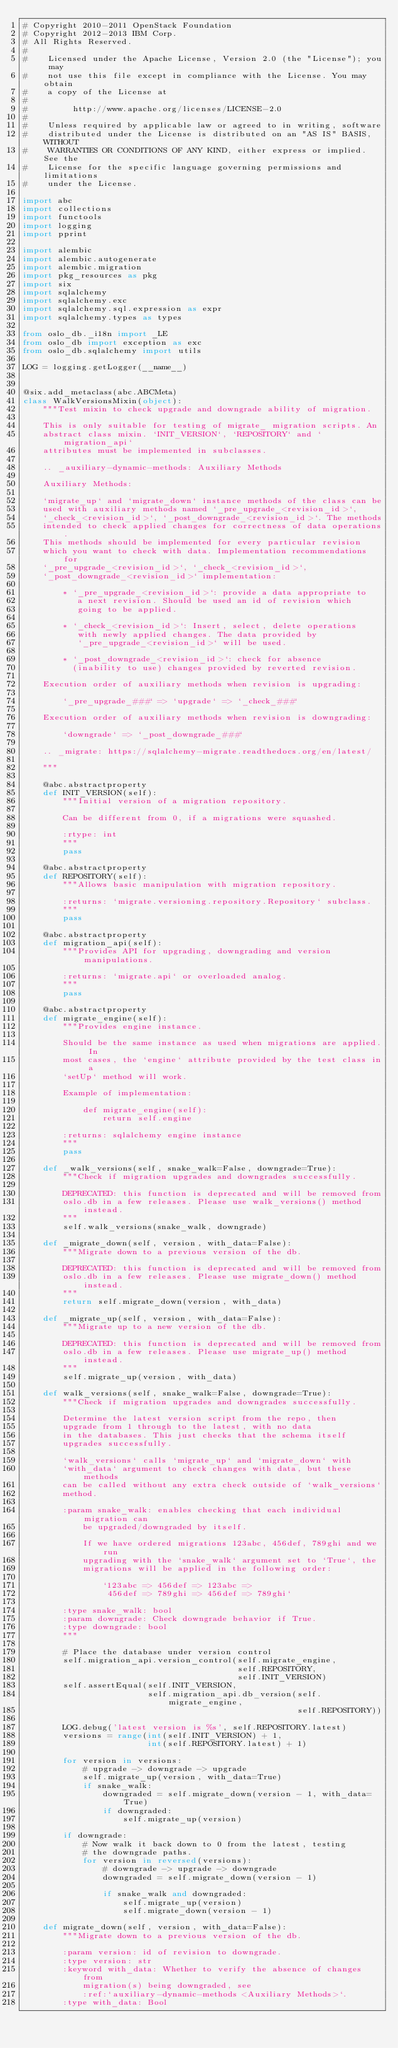<code> <loc_0><loc_0><loc_500><loc_500><_Python_># Copyright 2010-2011 OpenStack Foundation
# Copyright 2012-2013 IBM Corp.
# All Rights Reserved.
#
#    Licensed under the Apache License, Version 2.0 (the "License"); you may
#    not use this file except in compliance with the License. You may obtain
#    a copy of the License at
#
#         http://www.apache.org/licenses/LICENSE-2.0
#
#    Unless required by applicable law or agreed to in writing, software
#    distributed under the License is distributed on an "AS IS" BASIS, WITHOUT
#    WARRANTIES OR CONDITIONS OF ANY KIND, either express or implied. See the
#    License for the specific language governing permissions and limitations
#    under the License.

import abc
import collections
import functools
import logging
import pprint

import alembic
import alembic.autogenerate
import alembic.migration
import pkg_resources as pkg
import six
import sqlalchemy
import sqlalchemy.exc
import sqlalchemy.sql.expression as expr
import sqlalchemy.types as types

from oslo_db._i18n import _LE
from oslo_db import exception as exc
from oslo_db.sqlalchemy import utils

LOG = logging.getLogger(__name__)


@six.add_metaclass(abc.ABCMeta)
class WalkVersionsMixin(object):
    """Test mixin to check upgrade and downgrade ability of migration.

    This is only suitable for testing of migrate_ migration scripts. An
    abstract class mixin. `INIT_VERSION`, `REPOSITORY` and `migration_api`
    attributes must be implemented in subclasses.

    .. _auxiliary-dynamic-methods: Auxiliary Methods

    Auxiliary Methods:

    `migrate_up` and `migrate_down` instance methods of the class can be
    used with auxiliary methods named `_pre_upgrade_<revision_id>`,
    `_check_<revision_id>`, `_post_downgrade_<revision_id>`. The methods
    intended to check applied changes for correctness of data operations.
    This methods should be implemented for every particular revision
    which you want to check with data. Implementation recommendations for
    `_pre_upgrade_<revision_id>`, `_check_<revision_id>`,
    `_post_downgrade_<revision_id>` implementation:

        * `_pre_upgrade_<revision_id>`: provide a data appropriate to
           a next revision. Should be used an id of revision which
           going to be applied.

        * `_check_<revision_id>`: Insert, select, delete operations
           with newly applied changes. The data provided by
           `_pre_upgrade_<revision_id>` will be used.

        * `_post_downgrade_<revision_id>`: check for absence
          (inability to use) changes provided by reverted revision.

    Execution order of auxiliary methods when revision is upgrading:

        `_pre_upgrade_###` => `upgrade` => `_check_###`

    Execution order of auxiliary methods when revision is downgrading:

        `downgrade` => `_post_downgrade_###`

    .. _migrate: https://sqlalchemy-migrate.readthedocs.org/en/latest/

    """

    @abc.abstractproperty
    def INIT_VERSION(self):
        """Initial version of a migration repository.

        Can be different from 0, if a migrations were squashed.

        :rtype: int
        """
        pass

    @abc.abstractproperty
    def REPOSITORY(self):
        """Allows basic manipulation with migration repository.

        :returns: `migrate.versioning.repository.Repository` subclass.
        """
        pass

    @abc.abstractproperty
    def migration_api(self):
        """Provides API for upgrading, downgrading and version manipulations.

        :returns: `migrate.api` or overloaded analog.
        """
        pass

    @abc.abstractproperty
    def migrate_engine(self):
        """Provides engine instance.

        Should be the same instance as used when migrations are applied. In
        most cases, the `engine` attribute provided by the test class in a
        `setUp` method will work.

        Example of implementation:

            def migrate_engine(self):
                return self.engine

        :returns: sqlalchemy engine instance
        """
        pass

    def _walk_versions(self, snake_walk=False, downgrade=True):
        """Check if migration upgrades and downgrades successfully.

        DEPRECATED: this function is deprecated and will be removed from
        oslo.db in a few releases. Please use walk_versions() method instead.
        """
        self.walk_versions(snake_walk, downgrade)

    def _migrate_down(self, version, with_data=False):
        """Migrate down to a previous version of the db.

        DEPRECATED: this function is deprecated and will be removed from
        oslo.db in a few releases. Please use migrate_down() method instead.
        """
        return self.migrate_down(version, with_data)

    def _migrate_up(self, version, with_data=False):
        """Migrate up to a new version of the db.

        DEPRECATED: this function is deprecated and will be removed from
        oslo.db in a few releases. Please use migrate_up() method instead.
        """
        self.migrate_up(version, with_data)

    def walk_versions(self, snake_walk=False, downgrade=True):
        """Check if migration upgrades and downgrades successfully.

        Determine the latest version script from the repo, then
        upgrade from 1 through to the latest, with no data
        in the databases. This just checks that the schema itself
        upgrades successfully.

        `walk_versions` calls `migrate_up` and `migrate_down` with
        `with_data` argument to check changes with data, but these methods
        can be called without any extra check outside of `walk_versions`
        method.

        :param snake_walk: enables checking that each individual migration can
            be upgraded/downgraded by itself.

            If we have ordered migrations 123abc, 456def, 789ghi and we run
            upgrading with the `snake_walk` argument set to `True`, the
            migrations will be applied in the following order:

                `123abc => 456def => 123abc =>
                 456def => 789ghi => 456def => 789ghi`

        :type snake_walk: bool
        :param downgrade: Check downgrade behavior if True.
        :type downgrade: bool
        """

        # Place the database under version control
        self.migration_api.version_control(self.migrate_engine,
                                           self.REPOSITORY,
                                           self.INIT_VERSION)
        self.assertEqual(self.INIT_VERSION,
                         self.migration_api.db_version(self.migrate_engine,
                                                       self.REPOSITORY))

        LOG.debug('latest version is %s', self.REPOSITORY.latest)
        versions = range(int(self.INIT_VERSION) + 1,
                         int(self.REPOSITORY.latest) + 1)

        for version in versions:
            # upgrade -> downgrade -> upgrade
            self.migrate_up(version, with_data=True)
            if snake_walk:
                downgraded = self.migrate_down(version - 1, with_data=True)
                if downgraded:
                    self.migrate_up(version)

        if downgrade:
            # Now walk it back down to 0 from the latest, testing
            # the downgrade paths.
            for version in reversed(versions):
                # downgrade -> upgrade -> downgrade
                downgraded = self.migrate_down(version - 1)

                if snake_walk and downgraded:
                    self.migrate_up(version)
                    self.migrate_down(version - 1)

    def migrate_down(self, version, with_data=False):
        """Migrate down to a previous version of the db.

        :param version: id of revision to downgrade.
        :type version: str
        :keyword with_data: Whether to verify the absence of changes from
            migration(s) being downgraded, see
            :ref:`auxiliary-dynamic-methods <Auxiliary Methods>`.
        :type with_data: Bool</code> 